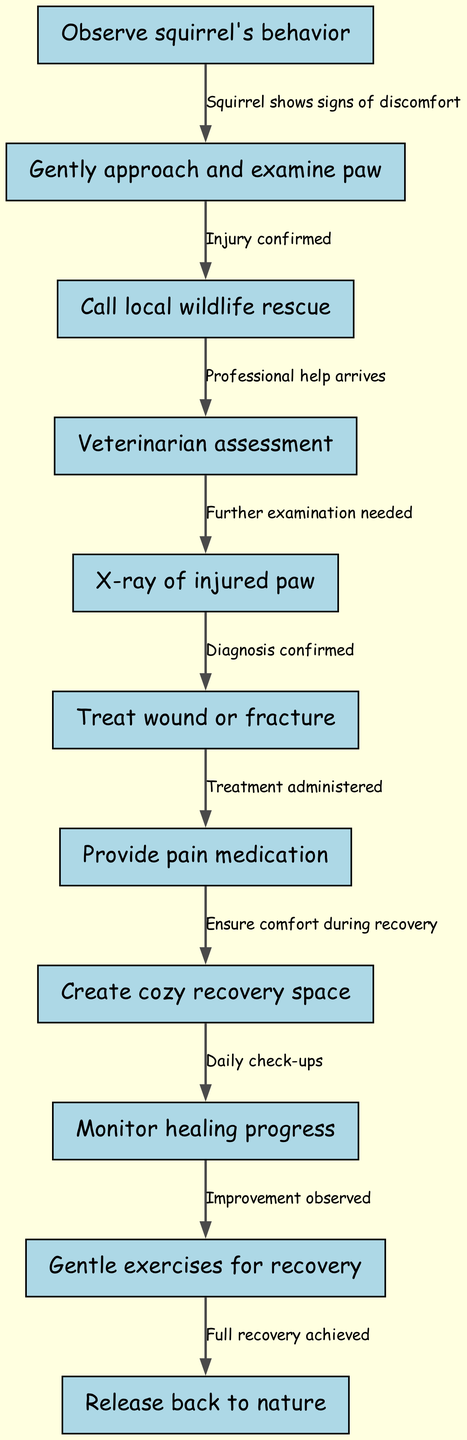What is the first step in the clinical pathway? The first step in the clinical pathway is represented by the node with ID 1, which states "Observe squirrel's behavior." This is where the assessment begins before any physical examination is done.
Answer: Observe squirrel's behavior How many nodes are in the diagram? The diagram consists of 11 unique nodes detailing the steps in treating the squirrel's injured paw. Counting all the nodes listed, we find the total number to be 11.
Answer: 11 What is the outcome after treating the wound or fracture? After treating the wound or fracture, as shown in the edge from node 6 to node 7, the next step is to "Provide pain medication", which helps comfort the squirrel after treatment.
Answer: Provide pain medication Which step follows after monitoring healing progress? The step that follows "Monitor healing progress", which is node 9, is "Gentle exercises for recovery," node 10. This indicates that healing is sufficiently observed to warrant physical activity.
Answer: Gentle exercises for recovery What relationship exists between confirming an injury and calling for help? The relationship between confirming an injury, represented by moving from node 2 to node 3, is that an injury being confirmed necessitates that you "Call local wildlife rescue" for professional assistance.
Answer: Call local wildlife rescue What must be ensured during the recovery phase? During the recovery phase, as indicated by the edge from node 7 to node 8, you must "Ensure comfort during recovery" by creating a cozy recovery space for the squirrel.
Answer: Ensure comfort during recovery What follows after the veterinarian assessment? Following the "Veterinarian assessment" (node 4), the next step is "X-ray of injured paw" (node 5). This step is essential for further examination and diagnosis of the injury.
Answer: X-ray of injured paw At what point is the squirrel ready to be released back into nature? The point at which the squirrel is prepared to be released back into nature occurs after "Full recovery achieved" (node 11), indicating a successful treatment and rehabilitation process.
Answer: Release back to nature 